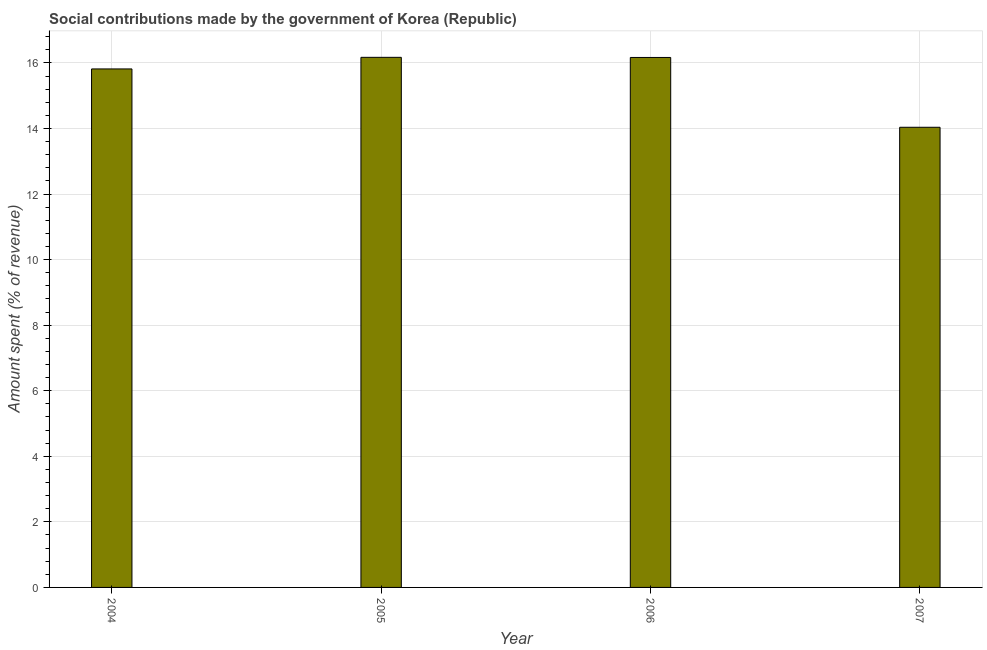Does the graph contain any zero values?
Keep it short and to the point. No. Does the graph contain grids?
Your response must be concise. Yes. What is the title of the graph?
Your answer should be compact. Social contributions made by the government of Korea (Republic). What is the label or title of the Y-axis?
Keep it short and to the point. Amount spent (% of revenue). What is the amount spent in making social contributions in 2007?
Offer a terse response. 14.04. Across all years, what is the maximum amount spent in making social contributions?
Your answer should be very brief. 16.17. Across all years, what is the minimum amount spent in making social contributions?
Provide a short and direct response. 14.04. In which year was the amount spent in making social contributions minimum?
Give a very brief answer. 2007. What is the sum of the amount spent in making social contributions?
Your response must be concise. 62.2. What is the difference between the amount spent in making social contributions in 2004 and 2005?
Ensure brevity in your answer.  -0.35. What is the average amount spent in making social contributions per year?
Make the answer very short. 15.55. What is the median amount spent in making social contributions?
Offer a terse response. 15.99. What is the ratio of the amount spent in making social contributions in 2004 to that in 2007?
Keep it short and to the point. 1.13. What is the difference between the highest and the second highest amount spent in making social contributions?
Keep it short and to the point. 0. What is the difference between the highest and the lowest amount spent in making social contributions?
Offer a terse response. 2.13. What is the difference between two consecutive major ticks on the Y-axis?
Your answer should be compact. 2. Are the values on the major ticks of Y-axis written in scientific E-notation?
Provide a short and direct response. No. What is the Amount spent (% of revenue) of 2004?
Offer a terse response. 15.82. What is the Amount spent (% of revenue) of 2005?
Your response must be concise. 16.17. What is the Amount spent (% of revenue) in 2006?
Provide a succinct answer. 16.17. What is the Amount spent (% of revenue) in 2007?
Keep it short and to the point. 14.04. What is the difference between the Amount spent (% of revenue) in 2004 and 2005?
Your answer should be very brief. -0.35. What is the difference between the Amount spent (% of revenue) in 2004 and 2006?
Make the answer very short. -0.35. What is the difference between the Amount spent (% of revenue) in 2004 and 2007?
Ensure brevity in your answer.  1.78. What is the difference between the Amount spent (% of revenue) in 2005 and 2006?
Make the answer very short. 0. What is the difference between the Amount spent (% of revenue) in 2005 and 2007?
Your response must be concise. 2.13. What is the difference between the Amount spent (% of revenue) in 2006 and 2007?
Ensure brevity in your answer.  2.13. What is the ratio of the Amount spent (% of revenue) in 2004 to that in 2005?
Provide a short and direct response. 0.98. What is the ratio of the Amount spent (% of revenue) in 2004 to that in 2006?
Provide a succinct answer. 0.98. What is the ratio of the Amount spent (% of revenue) in 2004 to that in 2007?
Your answer should be compact. 1.13. What is the ratio of the Amount spent (% of revenue) in 2005 to that in 2006?
Make the answer very short. 1. What is the ratio of the Amount spent (% of revenue) in 2005 to that in 2007?
Keep it short and to the point. 1.15. What is the ratio of the Amount spent (% of revenue) in 2006 to that in 2007?
Offer a terse response. 1.15. 